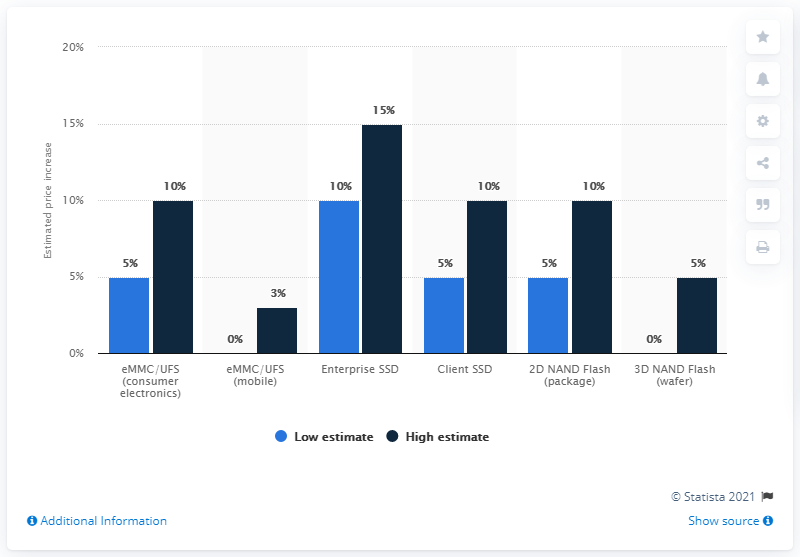Outline some significant characteristics in this image. The sum of the highest and lowest values of the blue bar is 10. The highest percentage in the blue chart is 10%. 